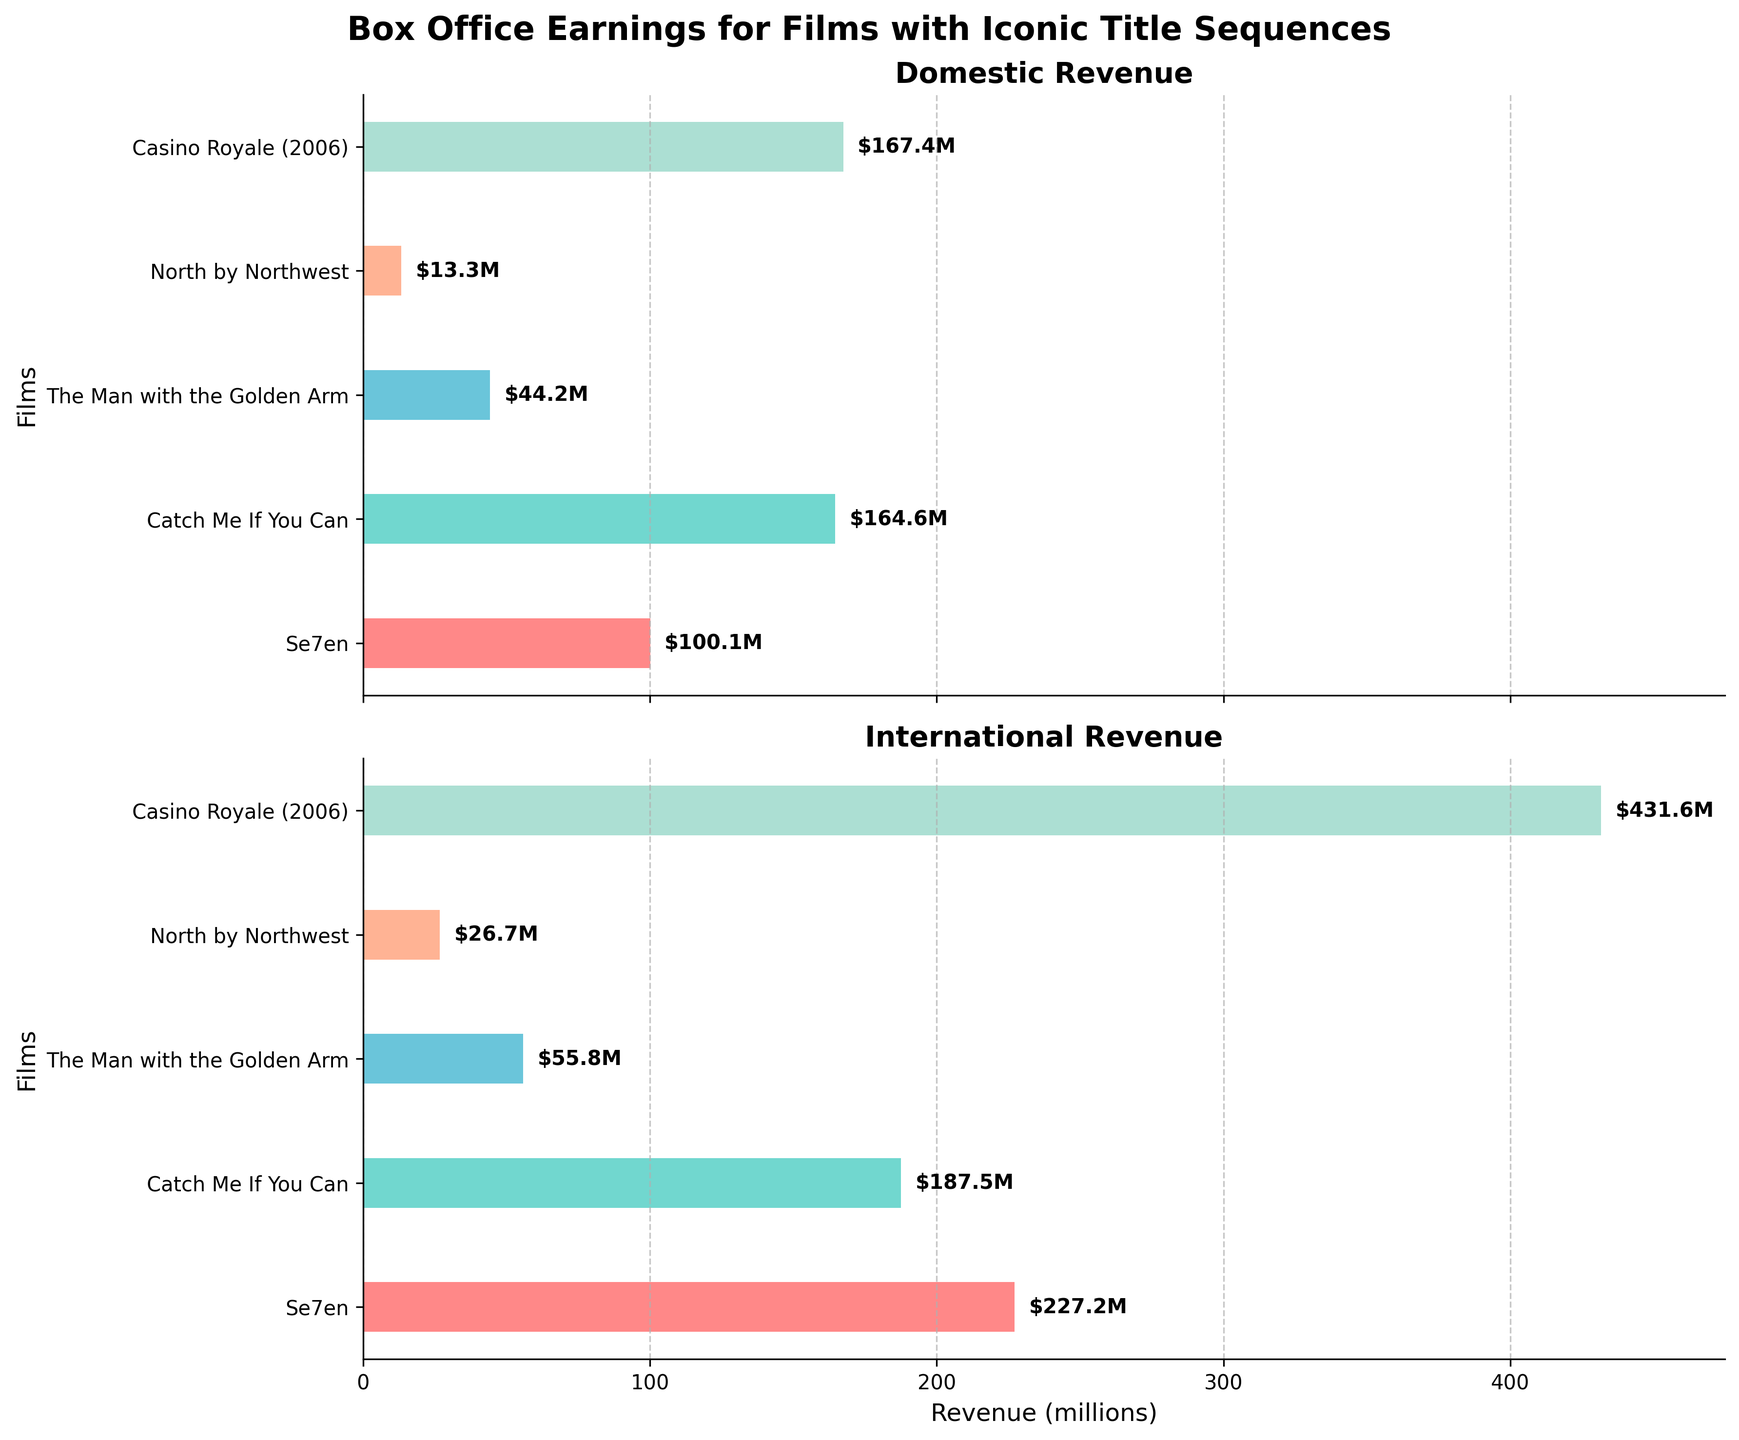What is the title of the whole figure? The title of the whole figure is located above both subplots. It reads "Box Office Earnings for Films with Iconic Title Sequences" in bold font.
Answer: Box Office Earnings for Films with Iconic Title Sequences Which film has the highest domestic revenue? Looking at the domestic revenue subplot, the film with the longest bar represents the highest domestic revenue. The longest bar belongs to "Casino Royale (2006)".
Answer: Casino Royale (2006) What is the domestic revenue for "Se7en"? On the domestic revenue subplot, locate the bar with the label "Se7en" and read the value. The text next to the bar indicates "$100.1M".
Answer: $100.1M Which film has more international revenue than domestic revenue? Compare the lengths of the bars for each film in both subplots. "Casino Royale (2006)" and "Se7en" have noticeably longer bars in the international revenue subplot.
Answer: Casino Royale (2006), Se7en What is the total revenue (domestic + international) for "Catch Me If You Can"? Add the domestic revenue of "$164.6M" to the international revenue of "$187.5M" for the film "Catch Me If You Can". The total is $164.6M + $187.5M = $352.1M.
Answer: $352.1M Which film has the least international revenue? The film with the shortest bar in the international revenue subplot has the least international revenue. "North by Northwest" has the shortest bar.
Answer: North by Northwest How much more is the international revenue compared to domestic revenue for "Casino Royale (2006)"? Subtract the domestic revenue from the international revenue for "Casino Royale (2006)". The international revenue is $431.6M and the domestic revenue is $167.4M. The difference is $431.6M - $167.4M = $264.2M.
Answer: $264.2M Which subplot shows international revenue? The subplots are titled "Domestic Revenue" and "International Revenue". The second subplot, titled "International Revenue", displays the international revenue.
Answer: Second subplot What's the total combined revenue for "The Man with the Golden Arm"? Add the domestic revenue of "$44.2M" to the international revenue of "$55.8M" for "The Man with the Golden Arm". The total is $44.2M + $55.8M = $100M.
Answer: $100M Who made the highest revenue internationally and how much was it? Identify the longest bar in the international revenue subplot. "Casino Royale (2006)" has the longest bar with revenue indicated as "$431.6M".
Answer: Casino Royale (2006), $431.6M 